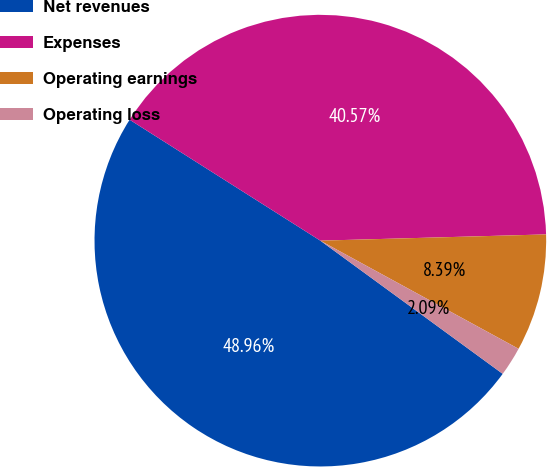Convert chart to OTSL. <chart><loc_0><loc_0><loc_500><loc_500><pie_chart><fcel>Net revenues<fcel>Expenses<fcel>Operating earnings<fcel>Operating loss<nl><fcel>48.96%<fcel>40.57%<fcel>8.39%<fcel>2.09%<nl></chart> 